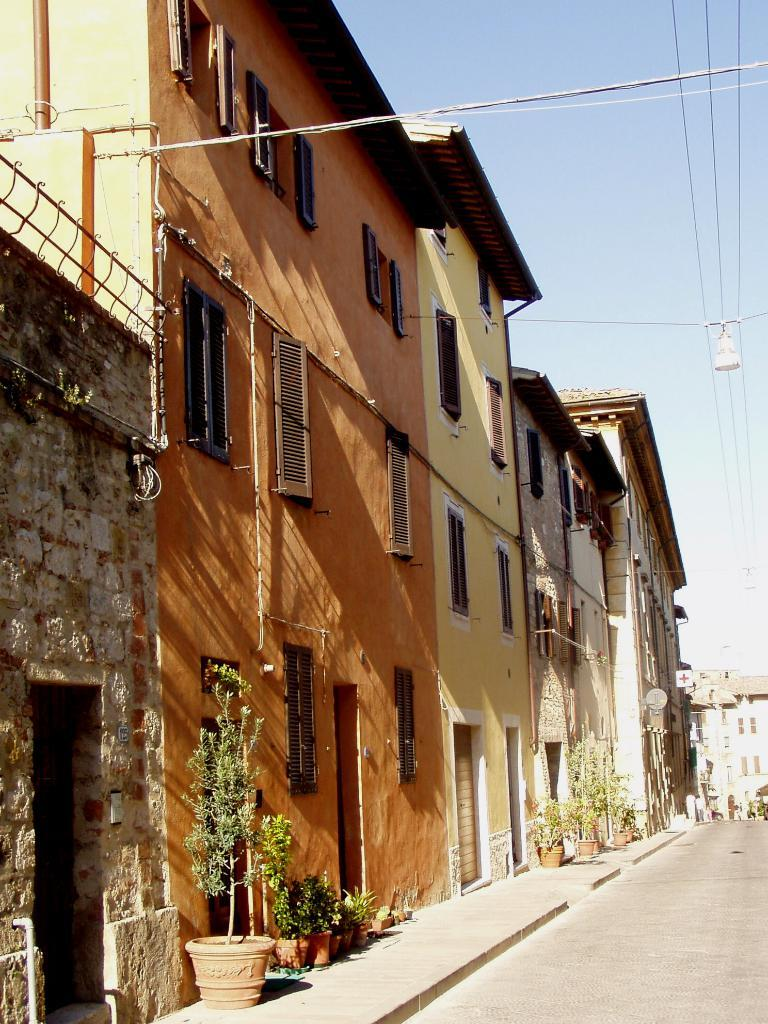What type of structures can be seen in the image? There are buildings in the image. What architectural elements are present in the image? There are walls, windows, doors, and a walkway visible in the image. What utilities can be seen in the image? Pipes are visible in the image. What natural elements are present in the image? Plants and the sky are visible in the image. What objects are used for holding plants in the image? Pots are visible in the image. What type of pathway is present in the image? There is a walkway in the image. What type of transportation infrastructure is present in the image? A road is present in the image. What is visible on the right side of the image? The sky and wires are visible on the right side of the image. Where is the stamp located in the image? There is no stamp present in the image. What type of playground equipment can be seen in the image? There is no swing or any playground equipment present in the image. 